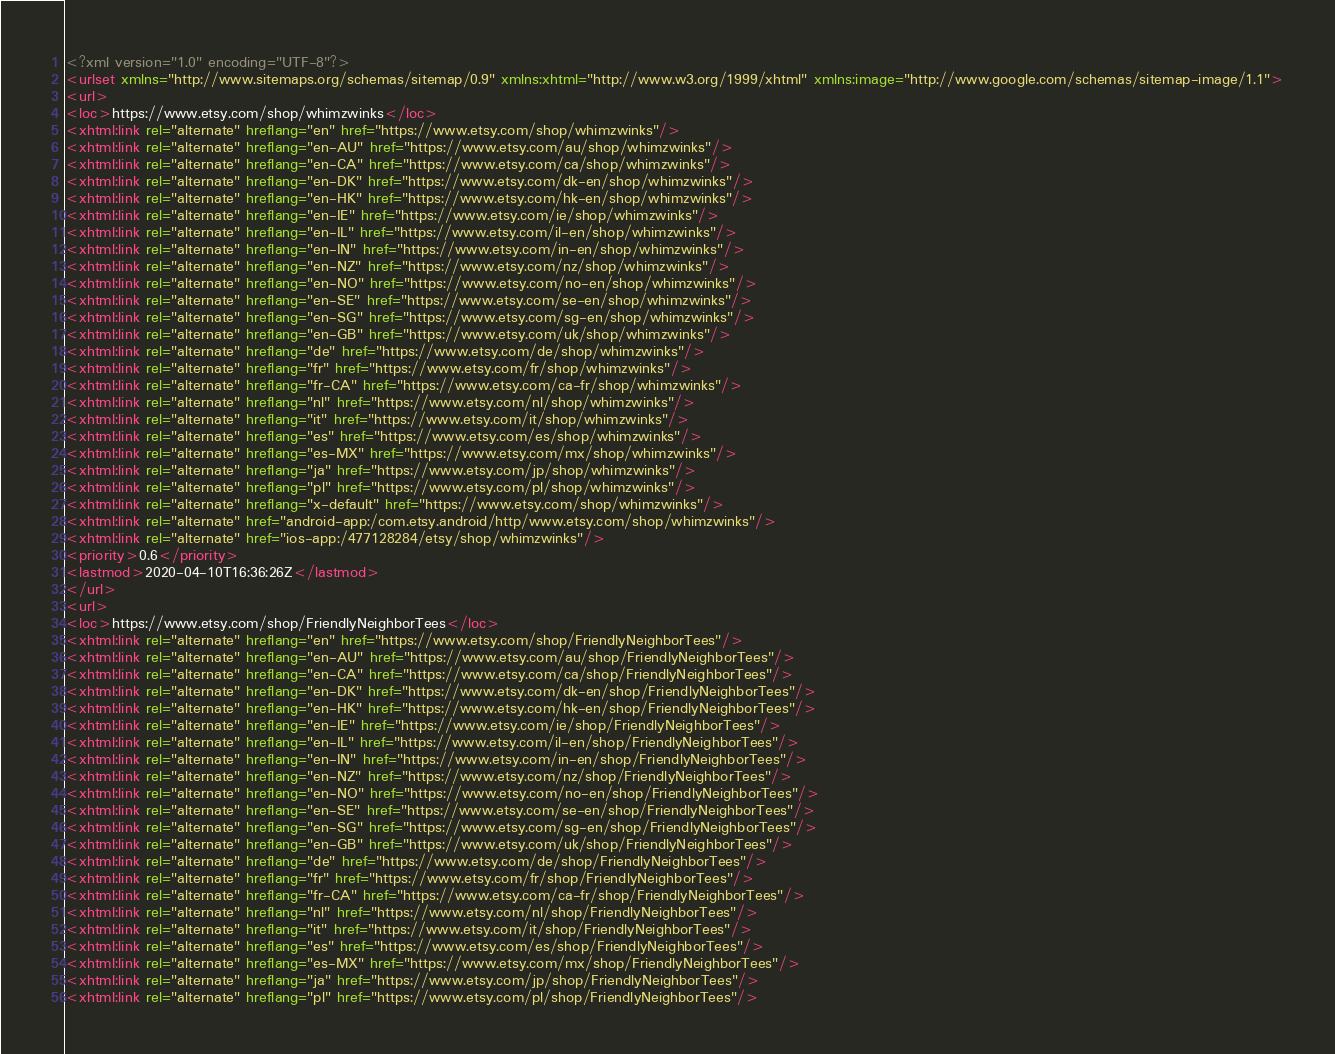Convert code to text. <code><loc_0><loc_0><loc_500><loc_500><_XML_><?xml version="1.0" encoding="UTF-8"?>
<urlset xmlns="http://www.sitemaps.org/schemas/sitemap/0.9" xmlns:xhtml="http://www.w3.org/1999/xhtml" xmlns:image="http://www.google.com/schemas/sitemap-image/1.1">
<url>
<loc>https://www.etsy.com/shop/whimzwinks</loc>
<xhtml:link rel="alternate" hreflang="en" href="https://www.etsy.com/shop/whimzwinks"/>
<xhtml:link rel="alternate" hreflang="en-AU" href="https://www.etsy.com/au/shop/whimzwinks"/>
<xhtml:link rel="alternate" hreflang="en-CA" href="https://www.etsy.com/ca/shop/whimzwinks"/>
<xhtml:link rel="alternate" hreflang="en-DK" href="https://www.etsy.com/dk-en/shop/whimzwinks"/>
<xhtml:link rel="alternate" hreflang="en-HK" href="https://www.etsy.com/hk-en/shop/whimzwinks"/>
<xhtml:link rel="alternate" hreflang="en-IE" href="https://www.etsy.com/ie/shop/whimzwinks"/>
<xhtml:link rel="alternate" hreflang="en-IL" href="https://www.etsy.com/il-en/shop/whimzwinks"/>
<xhtml:link rel="alternate" hreflang="en-IN" href="https://www.etsy.com/in-en/shop/whimzwinks"/>
<xhtml:link rel="alternate" hreflang="en-NZ" href="https://www.etsy.com/nz/shop/whimzwinks"/>
<xhtml:link rel="alternate" hreflang="en-NO" href="https://www.etsy.com/no-en/shop/whimzwinks"/>
<xhtml:link rel="alternate" hreflang="en-SE" href="https://www.etsy.com/se-en/shop/whimzwinks"/>
<xhtml:link rel="alternate" hreflang="en-SG" href="https://www.etsy.com/sg-en/shop/whimzwinks"/>
<xhtml:link rel="alternate" hreflang="en-GB" href="https://www.etsy.com/uk/shop/whimzwinks"/>
<xhtml:link rel="alternate" hreflang="de" href="https://www.etsy.com/de/shop/whimzwinks"/>
<xhtml:link rel="alternate" hreflang="fr" href="https://www.etsy.com/fr/shop/whimzwinks"/>
<xhtml:link rel="alternate" hreflang="fr-CA" href="https://www.etsy.com/ca-fr/shop/whimzwinks"/>
<xhtml:link rel="alternate" hreflang="nl" href="https://www.etsy.com/nl/shop/whimzwinks"/>
<xhtml:link rel="alternate" hreflang="it" href="https://www.etsy.com/it/shop/whimzwinks"/>
<xhtml:link rel="alternate" hreflang="es" href="https://www.etsy.com/es/shop/whimzwinks"/>
<xhtml:link rel="alternate" hreflang="es-MX" href="https://www.etsy.com/mx/shop/whimzwinks"/>
<xhtml:link rel="alternate" hreflang="ja" href="https://www.etsy.com/jp/shop/whimzwinks"/>
<xhtml:link rel="alternate" hreflang="pl" href="https://www.etsy.com/pl/shop/whimzwinks"/>
<xhtml:link rel="alternate" hreflang="x-default" href="https://www.etsy.com/shop/whimzwinks"/>
<xhtml:link rel="alternate" href="android-app:/com.etsy.android/http/www.etsy.com/shop/whimzwinks"/>
<xhtml:link rel="alternate" href="ios-app:/477128284/etsy/shop/whimzwinks"/>
<priority>0.6</priority>
<lastmod>2020-04-10T16:36:26Z</lastmod>
</url>
<url>
<loc>https://www.etsy.com/shop/FriendlyNeighborTees</loc>
<xhtml:link rel="alternate" hreflang="en" href="https://www.etsy.com/shop/FriendlyNeighborTees"/>
<xhtml:link rel="alternate" hreflang="en-AU" href="https://www.etsy.com/au/shop/FriendlyNeighborTees"/>
<xhtml:link rel="alternate" hreflang="en-CA" href="https://www.etsy.com/ca/shop/FriendlyNeighborTees"/>
<xhtml:link rel="alternate" hreflang="en-DK" href="https://www.etsy.com/dk-en/shop/FriendlyNeighborTees"/>
<xhtml:link rel="alternate" hreflang="en-HK" href="https://www.etsy.com/hk-en/shop/FriendlyNeighborTees"/>
<xhtml:link rel="alternate" hreflang="en-IE" href="https://www.etsy.com/ie/shop/FriendlyNeighborTees"/>
<xhtml:link rel="alternate" hreflang="en-IL" href="https://www.etsy.com/il-en/shop/FriendlyNeighborTees"/>
<xhtml:link rel="alternate" hreflang="en-IN" href="https://www.etsy.com/in-en/shop/FriendlyNeighborTees"/>
<xhtml:link rel="alternate" hreflang="en-NZ" href="https://www.etsy.com/nz/shop/FriendlyNeighborTees"/>
<xhtml:link rel="alternate" hreflang="en-NO" href="https://www.etsy.com/no-en/shop/FriendlyNeighborTees"/>
<xhtml:link rel="alternate" hreflang="en-SE" href="https://www.etsy.com/se-en/shop/FriendlyNeighborTees"/>
<xhtml:link rel="alternate" hreflang="en-SG" href="https://www.etsy.com/sg-en/shop/FriendlyNeighborTees"/>
<xhtml:link rel="alternate" hreflang="en-GB" href="https://www.etsy.com/uk/shop/FriendlyNeighborTees"/>
<xhtml:link rel="alternate" hreflang="de" href="https://www.etsy.com/de/shop/FriendlyNeighborTees"/>
<xhtml:link rel="alternate" hreflang="fr" href="https://www.etsy.com/fr/shop/FriendlyNeighborTees"/>
<xhtml:link rel="alternate" hreflang="fr-CA" href="https://www.etsy.com/ca-fr/shop/FriendlyNeighborTees"/>
<xhtml:link rel="alternate" hreflang="nl" href="https://www.etsy.com/nl/shop/FriendlyNeighborTees"/>
<xhtml:link rel="alternate" hreflang="it" href="https://www.etsy.com/it/shop/FriendlyNeighborTees"/>
<xhtml:link rel="alternate" hreflang="es" href="https://www.etsy.com/es/shop/FriendlyNeighborTees"/>
<xhtml:link rel="alternate" hreflang="es-MX" href="https://www.etsy.com/mx/shop/FriendlyNeighborTees"/>
<xhtml:link rel="alternate" hreflang="ja" href="https://www.etsy.com/jp/shop/FriendlyNeighborTees"/>
<xhtml:link rel="alternate" hreflang="pl" href="https://www.etsy.com/pl/shop/FriendlyNeighborTees"/></code> 